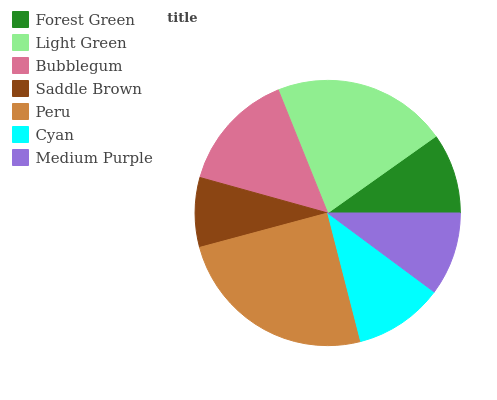Is Saddle Brown the minimum?
Answer yes or no. Yes. Is Peru the maximum?
Answer yes or no. Yes. Is Light Green the minimum?
Answer yes or no. No. Is Light Green the maximum?
Answer yes or no. No. Is Light Green greater than Forest Green?
Answer yes or no. Yes. Is Forest Green less than Light Green?
Answer yes or no. Yes. Is Forest Green greater than Light Green?
Answer yes or no. No. Is Light Green less than Forest Green?
Answer yes or no. No. Is Cyan the high median?
Answer yes or no. Yes. Is Cyan the low median?
Answer yes or no. Yes. Is Medium Purple the high median?
Answer yes or no. No. Is Bubblegum the low median?
Answer yes or no. No. 